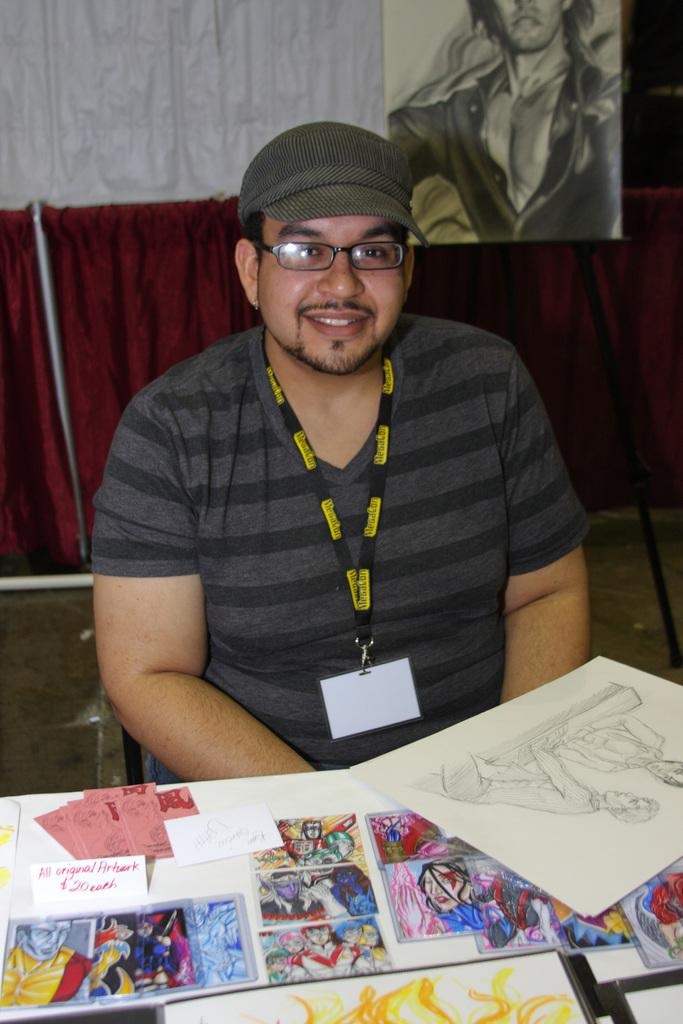What can be seen in the image? There is a person in the image. What is the person wearing? The person is wearing a cap. Where is the person sitting? The person is sitting in front of a table. What is on the table? There are pictures and a paper on the table. What can be seen in the background? There is a drawing visible in the background. What type of cobweb can be seen on the person's arm in the image? There is no cobweb visible on the person's arm in the image. What is the sun doing in the image? The sun is not present in the image; it is a drawing visible in the background. 